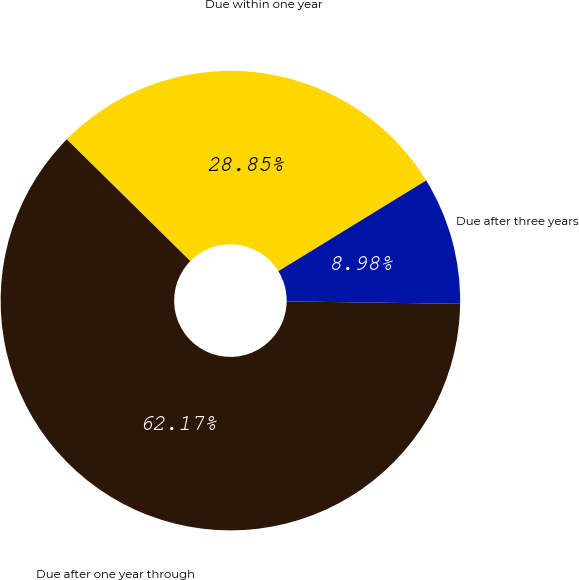Convert chart to OTSL. <chart><loc_0><loc_0><loc_500><loc_500><pie_chart><fcel>Due within one year<fcel>Due after one year through<fcel>Due after three years<nl><fcel>28.85%<fcel>62.16%<fcel>8.98%<nl></chart> 